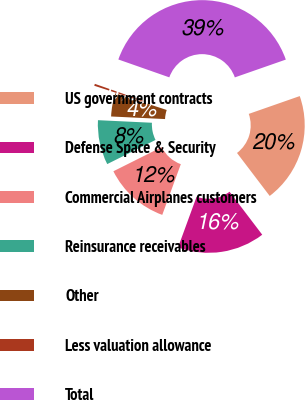Convert chart. <chart><loc_0><loc_0><loc_500><loc_500><pie_chart><fcel>US government contracts<fcel>Defense Space & Security<fcel>Commercial Airplanes customers<fcel>Reinsurance receivables<fcel>Other<fcel>Less valuation allowance<fcel>Total<nl><fcel>20.0%<fcel>15.93%<fcel>12.04%<fcel>8.14%<fcel>4.25%<fcel>0.36%<fcel>39.28%<nl></chart> 